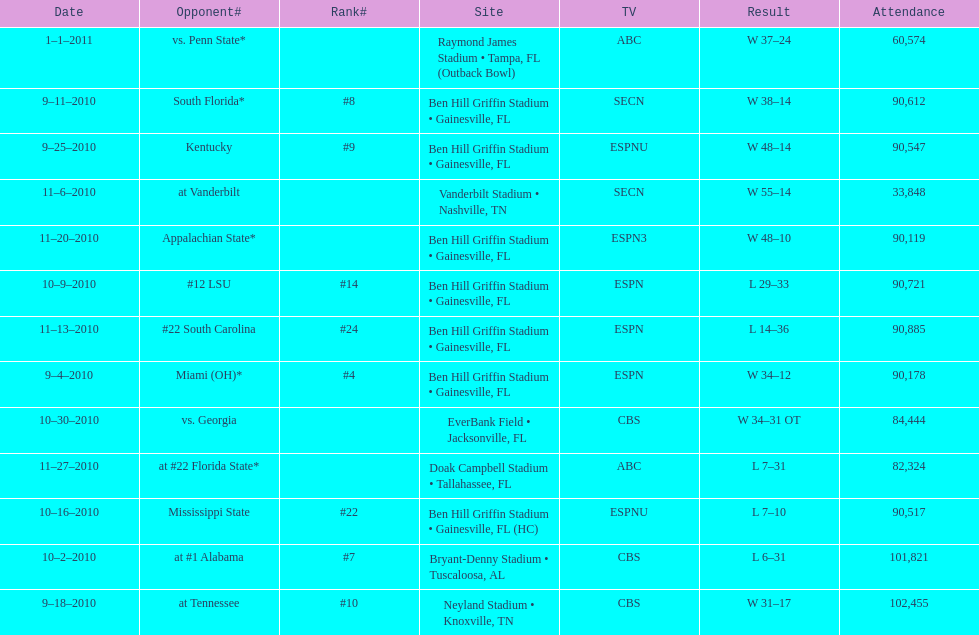How many consecutive weeks did the the gators win until the had their first lost in the 2010 season? 4. 